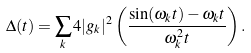<formula> <loc_0><loc_0><loc_500><loc_500>\Delta ( t ) = \sum _ { k } 4 | g _ { k } | ^ { 2 } \left ( \frac { \sin ( \omega _ { k } t ) - \omega _ { k } t } { \omega _ { k } ^ { 2 } t } \right ) .</formula> 